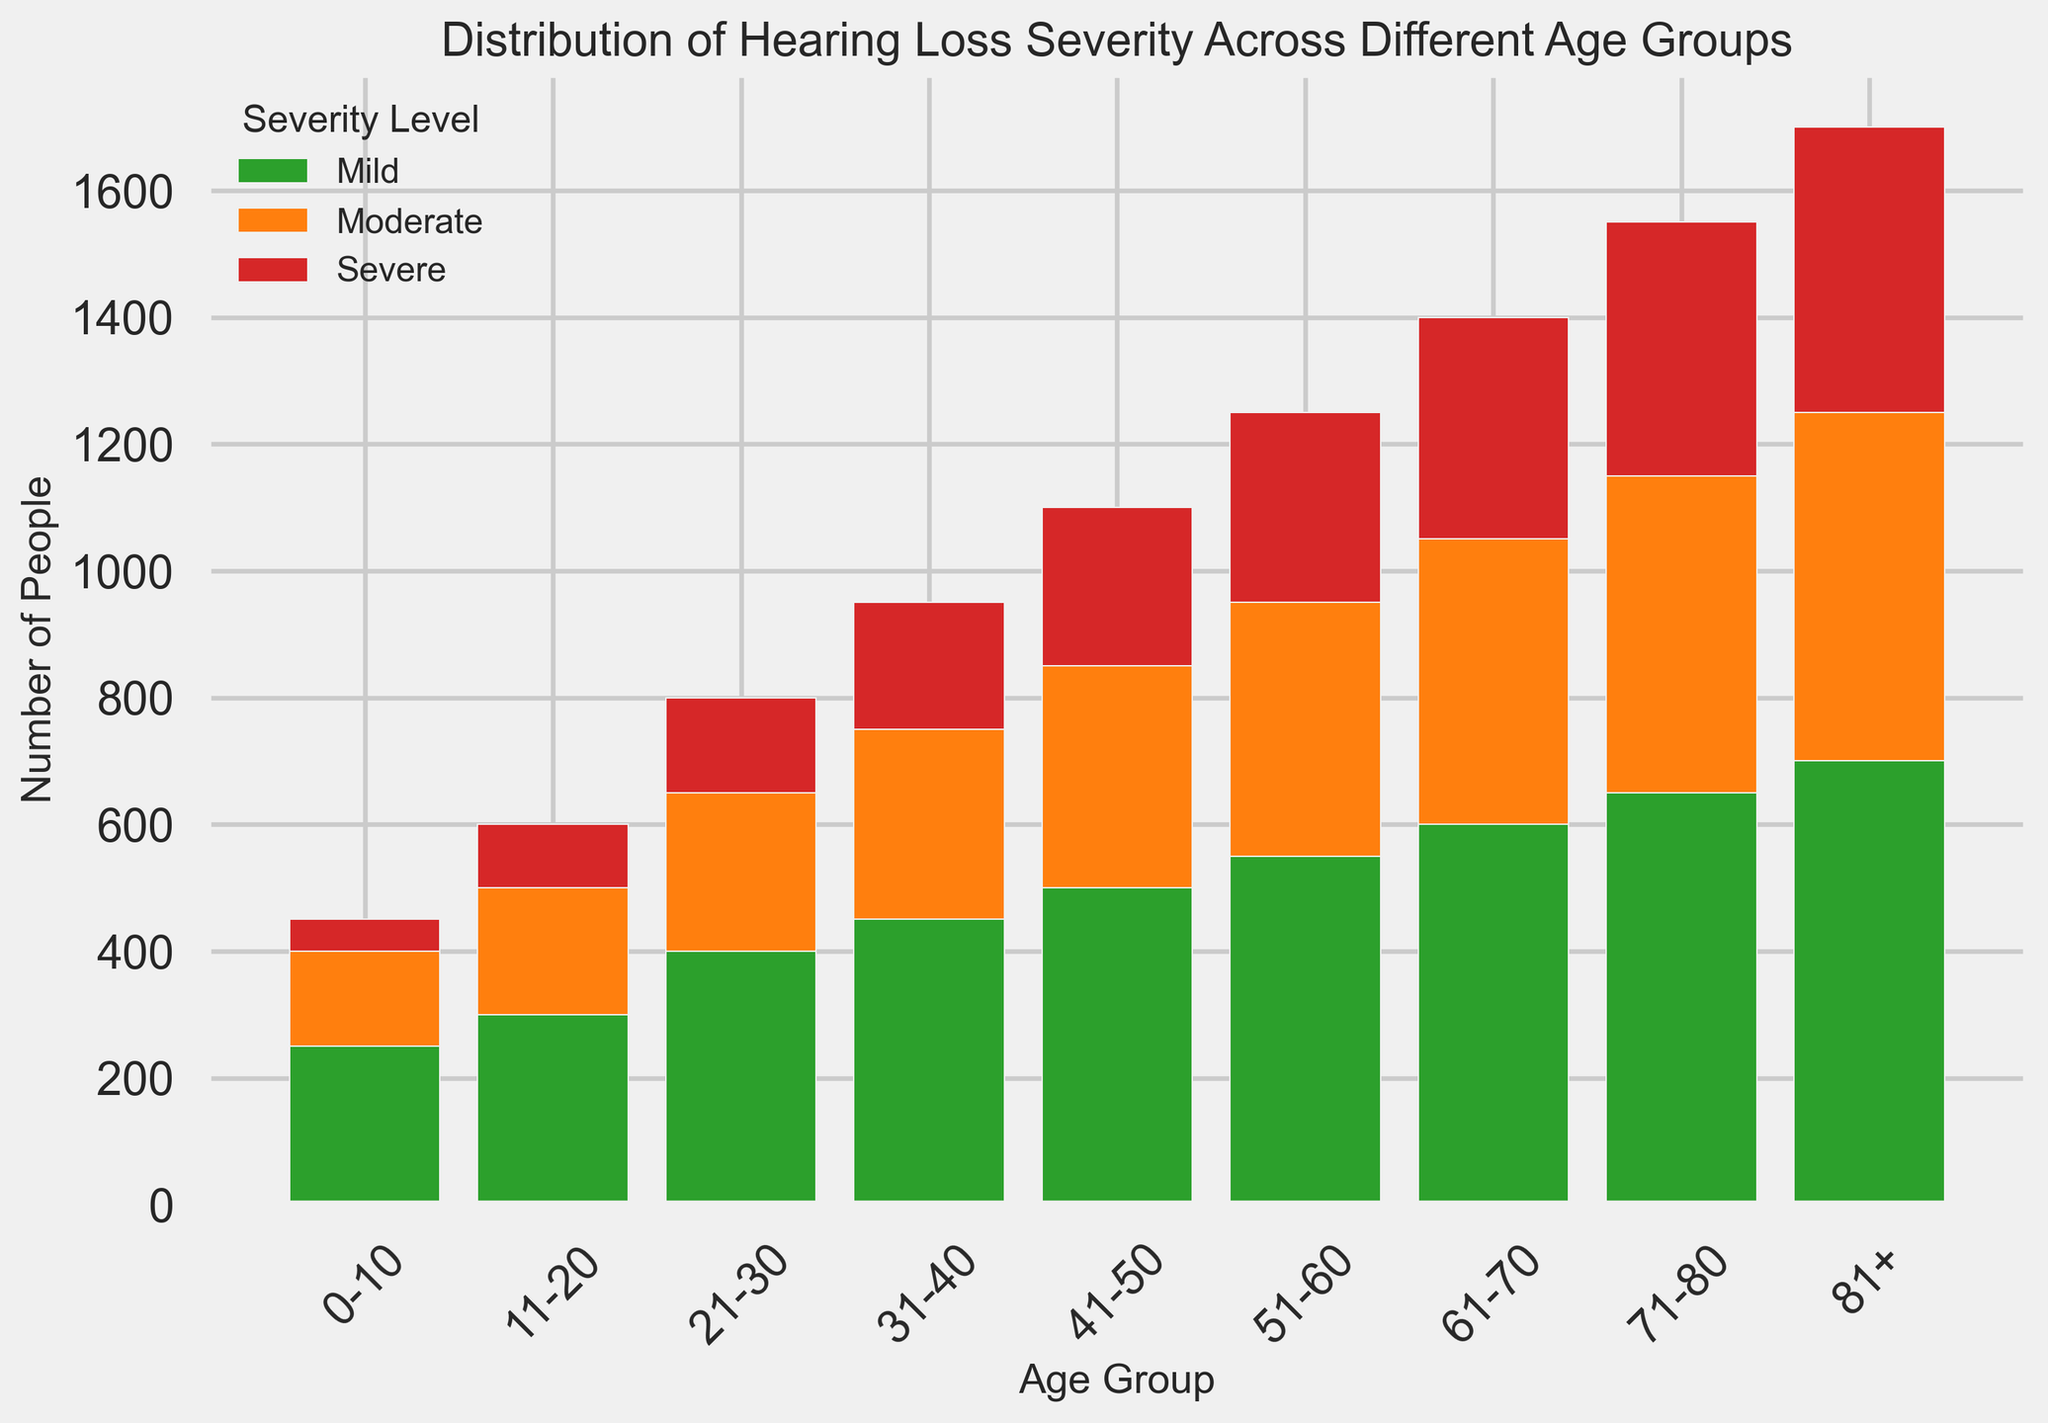What is the total number of people with moderate hearing loss across all age groups? To find the total number of people with moderate hearing loss, sum the counts for the 'Moderate' severity level across all age groups: 150 + 200 + 250 + 300 + 350 + 400 + 450 + 500 + 550 = 3,150
Answer: 3150 Which age group has the highest count of severe hearing loss? Check the tallest red bar (indicating severe hearing loss) among the age groups. The age group 81+ has the highest count with a value of 450.
Answer: 81+ How does the number of people with mild hearing loss in the 21-30 age group compare to those in the 51-60 age group? Compare the heights of the green bars for the age groups 21-30 and 51-60. The counts are 400 for 21-30 and 550 for 51-60. Since 550 > 400, 51-60 has more people with mild hearing loss.
Answer: 51-60 What is the combined total of people with severe hearing loss in the 41-50 and 51-60 age groups? Sum the counts of severe hearing loss in the 41-50 age group and the 51-60 age group: 250 + 300 = 550.
Answer: 550 Which severity level has the smallest number of people in the 0-10 age group? Compare the heights of the bars within the 0-10 age group. The smallest count is for the 'Severe' level with a value of 50.
Answer: Severe What is the difference in the number of people with moderate hearing loss between the 31-40 and 41-50 age groups? Subtract the count for the 31-40 age group from the 41-50 age group for moderate severity: 350 - 300 = 50.
Answer: 50 In which age group is the green bar the tallest? Identify the age group with the tallest green bar (indicating mild hearing loss). The 81+ age group has the tallest green bar.
Answer: 81+ Compare the total number of people in the 11-20 and 71-80 age groups. Which is larger? Sum the counts for each age group:
11-20: 300 + 200 + 100 = 600
71-80: 650 + 500 + 400 = 1,550
Since 1,550 > 600, 71-80 is larger.
Answer: 71-80 What is the average number of people with mild hearing loss across all age groups? Sum the counts of mild hearing loss in all age groups and divide by the number of age groups: (250 + 300 + 400 + 450 + 500 + 550 + 600 + 650 + 700) / 9 = 494.44
Answer: 494.44 Which age group exhibits the most balanced distribution of hearing loss severity levels? Look for the age group where the heights of the green, orange, and red bars are most similar. The 31-40 age group appears to exhibit a relatively balanced distribution with counts of 450 (mild), 300 (moderate), and 200 (severe).
Answer: 31-40 